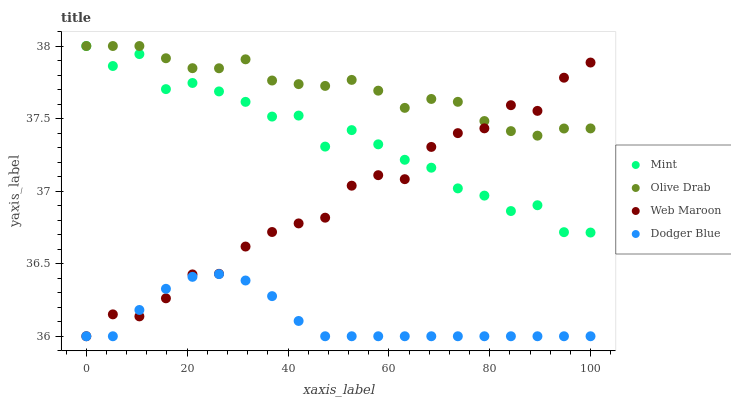Does Dodger Blue have the minimum area under the curve?
Answer yes or no. Yes. Does Olive Drab have the maximum area under the curve?
Answer yes or no. Yes. Does Mint have the minimum area under the curve?
Answer yes or no. No. Does Mint have the maximum area under the curve?
Answer yes or no. No. Is Dodger Blue the smoothest?
Answer yes or no. Yes. Is Mint the roughest?
Answer yes or no. Yes. Is Olive Drab the smoothest?
Answer yes or no. No. Is Olive Drab the roughest?
Answer yes or no. No. Does Web Maroon have the lowest value?
Answer yes or no. Yes. Does Mint have the lowest value?
Answer yes or no. No. Does Olive Drab have the highest value?
Answer yes or no. Yes. Does Dodger Blue have the highest value?
Answer yes or no. No. Is Dodger Blue less than Olive Drab?
Answer yes or no. Yes. Is Olive Drab greater than Dodger Blue?
Answer yes or no. Yes. Does Mint intersect Olive Drab?
Answer yes or no. Yes. Is Mint less than Olive Drab?
Answer yes or no. No. Is Mint greater than Olive Drab?
Answer yes or no. No. Does Dodger Blue intersect Olive Drab?
Answer yes or no. No. 